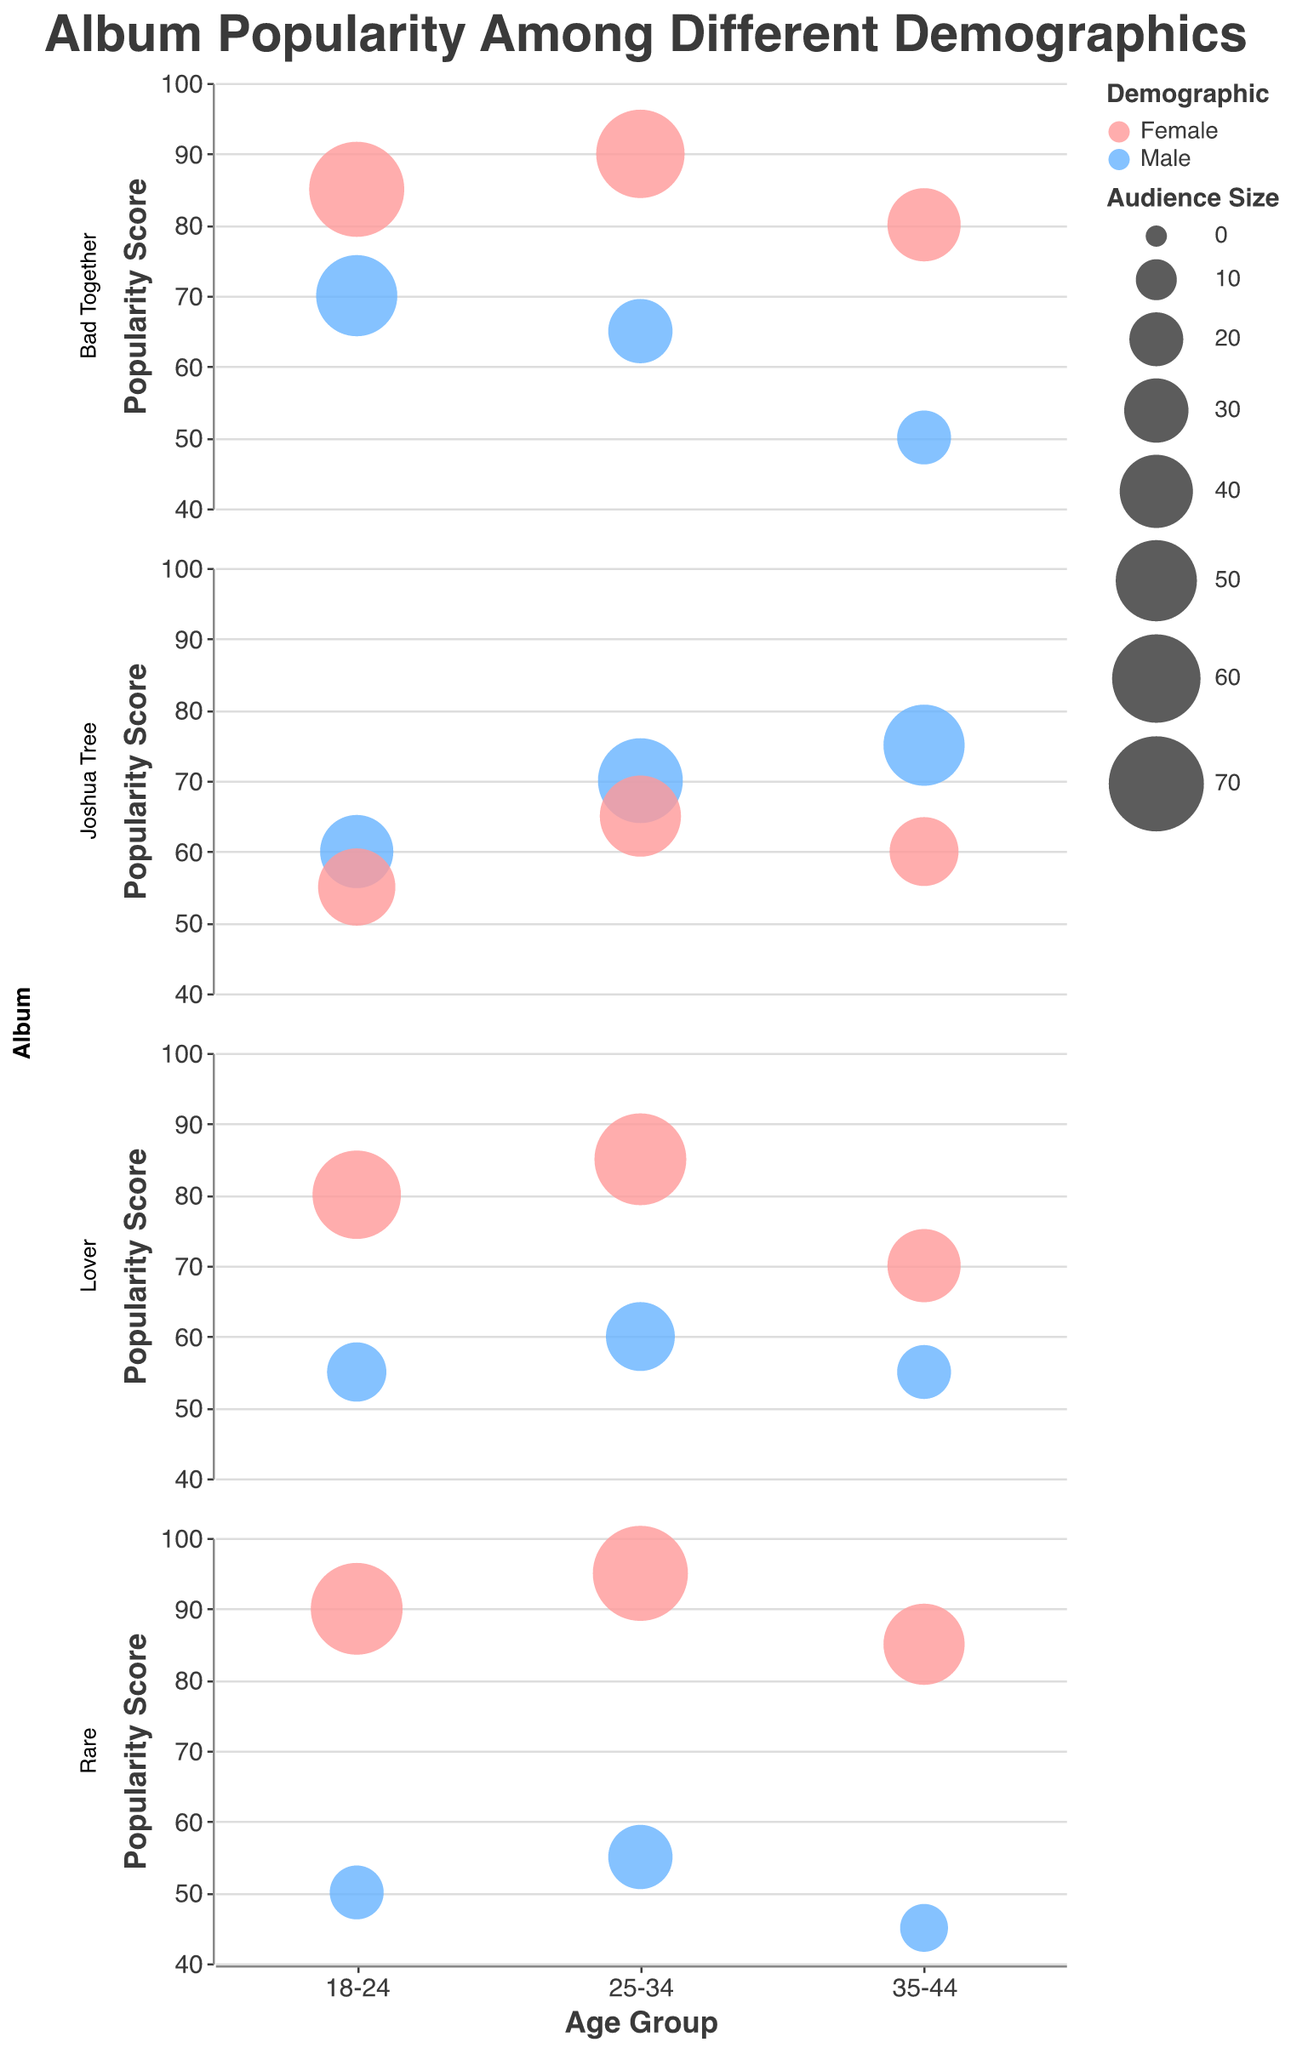What's the title of the figure? The title of the figure is prominently displayed at the top.
Answer: Album Popularity Among Different Demographics What is the vertical axis representing? The vertical axis represents the popularity score, ranging from 40 to 100.
Answer: Popularity Score Which demographic has the largest bubble size in the "Bad Together" album? In the "Bad Together" album, among all demographic groups, the largest bubble size is for Females in the 18-24 age group.
Answer: Females 18-24 What's the maximum popularity score for the "Joshua Tree" album and for which demographic and age group? The maximum popularity score for the "Joshua Tree" album is 75, which is for Males in the 35-44 age group.
Answer: Males 35-44 Compare the popularity score for "Lover" among Males and Females in the 25-34 age group. For the "Lover" album in the 25-34 age group, Males have a popularity score of 60, while Females have a higher score of 85.
Answer: Females have a higher score of 85 What is the average popularity score for "Rare" among all Female age groups? The popularity scores for "Rare" among all Female age groups are 90, 95, and 85. The average is (90 + 95 + 85) / 3 = 270 / 3 = 90.
Answer: 90 How does the popularity score of "Bad Together" for Females in the 18-24 age group compare to "Joshua Tree" in the same demographic and age group? For Females in the 18-24 age group, "Bad Together" has a popularity score of 85 while "Joshua Tree" has a lower score of 55.
Answer: "Bad Together" has a higher score of 85 Which age group has the smallest popularity score for "Rare" among Males? For the "Rare" album, among Males, the 35-44 age group has the smallest popularity score of 45.
Answer: 35-44 age group Identify the album that has the highest popularity score in the Male demographic. The highest popularity score in the Male demographic is found in the "Joshua Tree" album in the 35-44 age group, with a score of 75.
Answer: Joshua Tree What is the difference in bubble sizes between Males and Females in the 25-34 age group for the "Bad Together" album? For "Bad Together" in the 25-34 age group, the bubble size for Males is 30 and for Females is 60. The difference is 60 - 30 = 30.
Answer: 30 